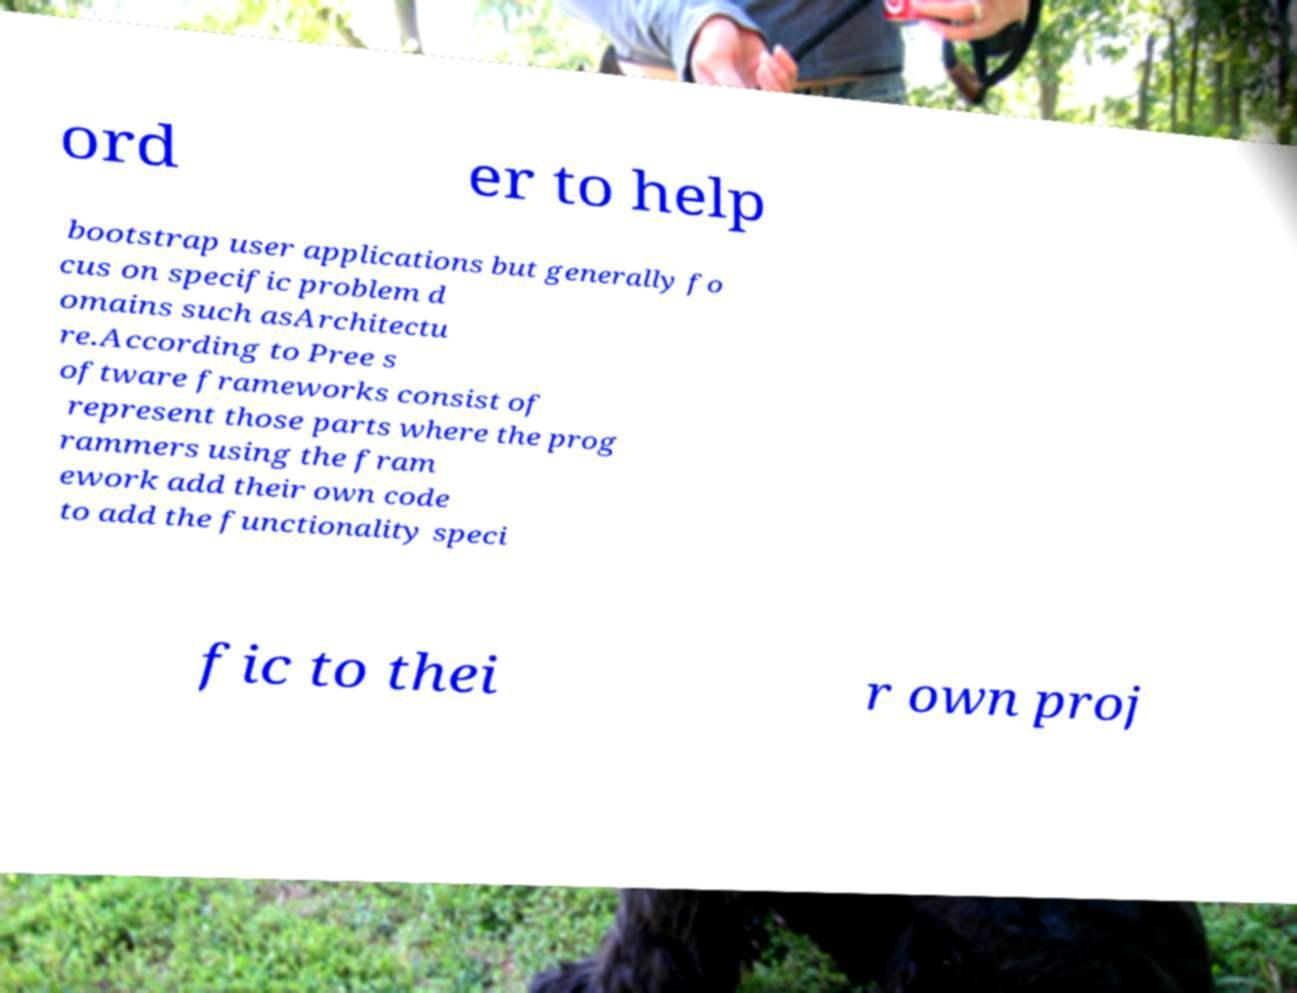Please identify and transcribe the text found in this image. ord er to help bootstrap user applications but generally fo cus on specific problem d omains such asArchitectu re.According to Pree s oftware frameworks consist of represent those parts where the prog rammers using the fram ework add their own code to add the functionality speci fic to thei r own proj 